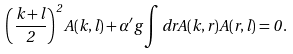Convert formula to latex. <formula><loc_0><loc_0><loc_500><loc_500>\left ( \frac { k + l } { 2 } \right ) ^ { 2 } A ( k , l ) + { \alpha ^ { \prime } } g \int d r A ( k , r ) A ( r , l ) = 0 \, .</formula> 